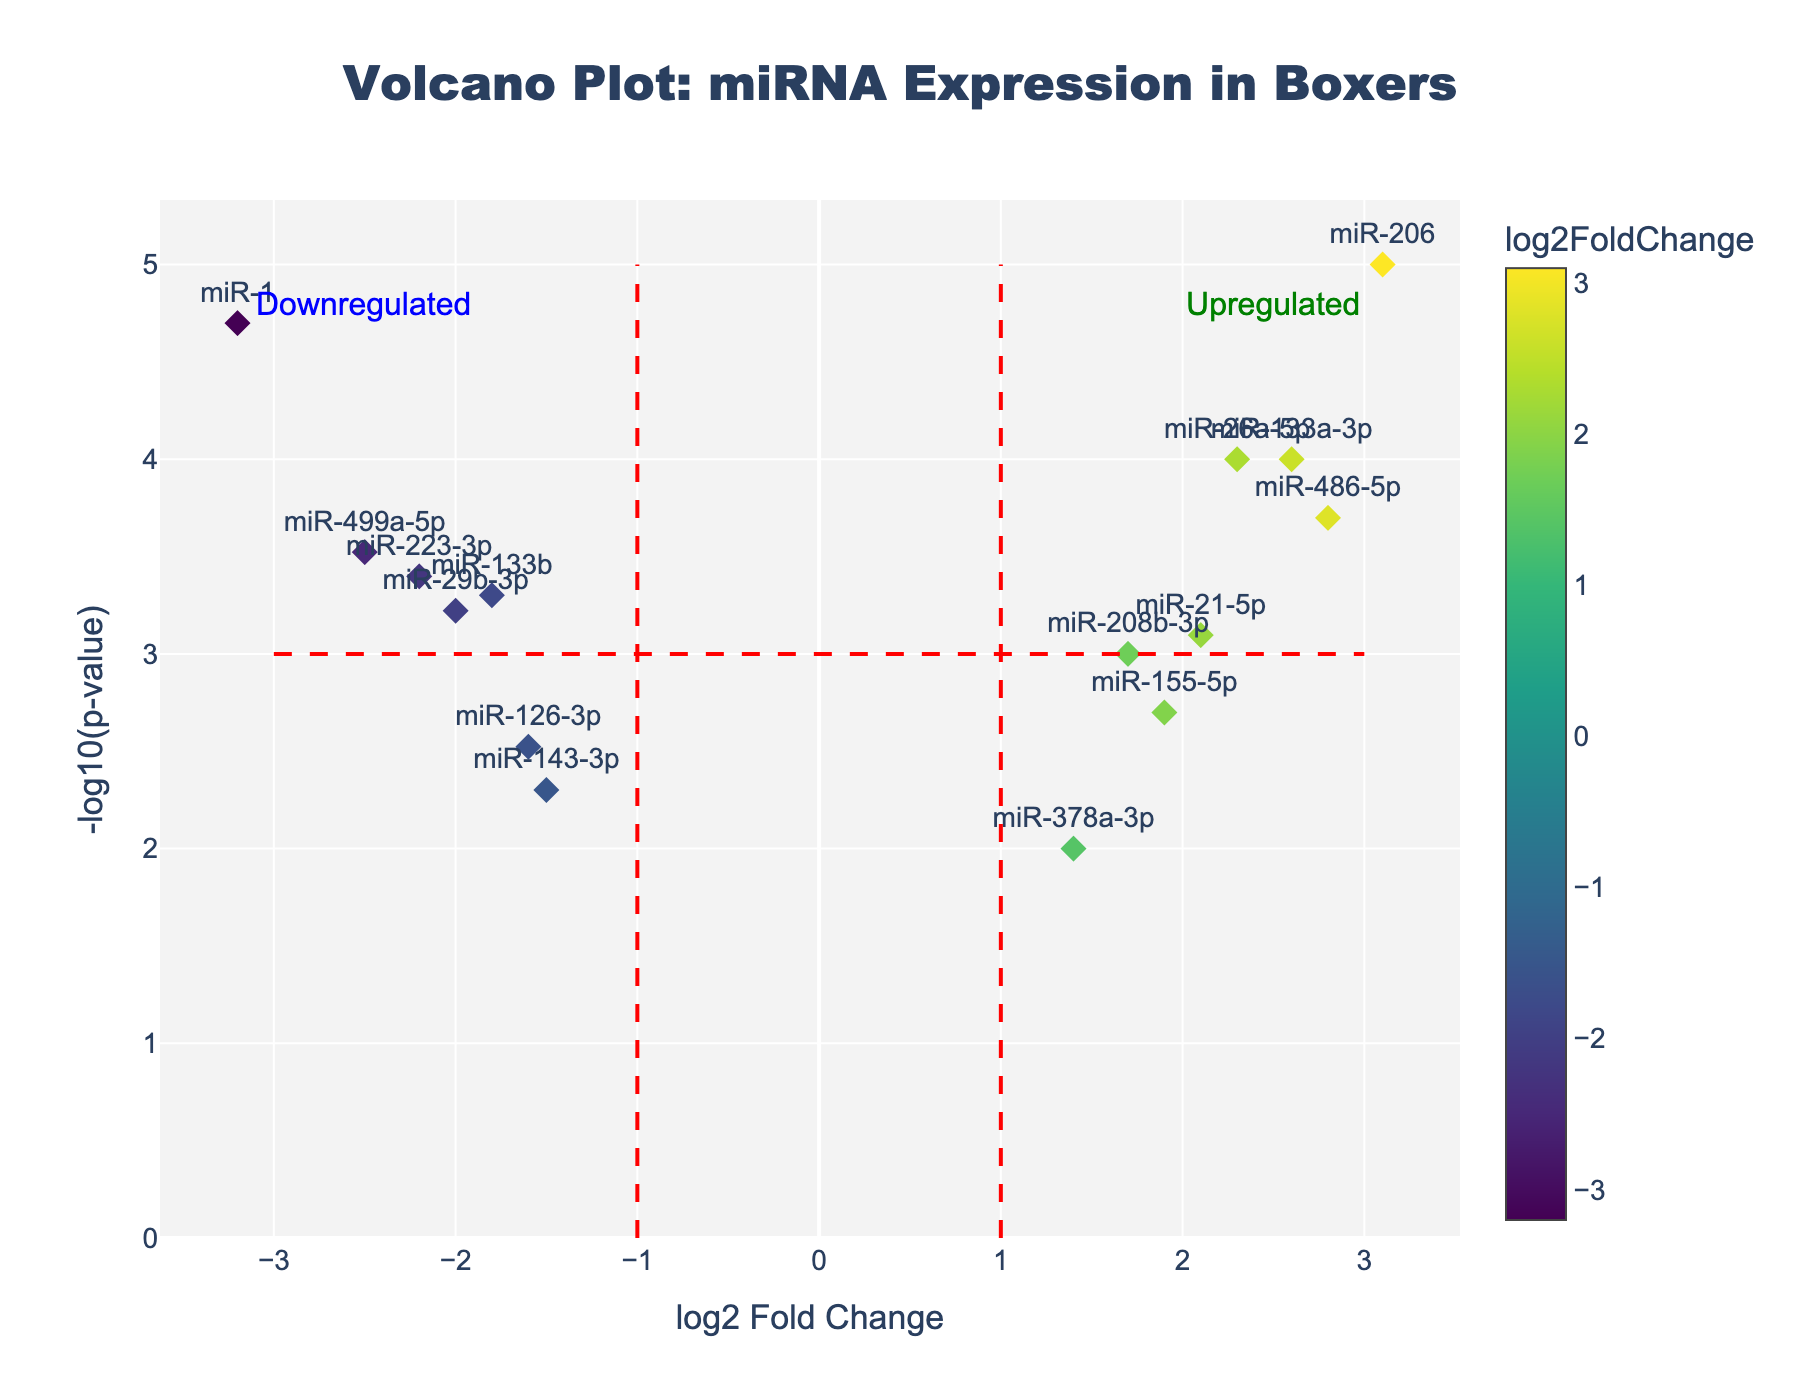Which miRNA has the highest -log10(p-value)? The highest -log10(p-value) value means the most significant p-value. By looking at the y-axis of the Volcano Plot, miR-206 is at the highest point.
Answer: miR-206 How many miRNAs are showing a log2 Fold Change greater than 2? Count the data points on the x-axis that are positioned to the right of 2. The miRNAs miR-26a-5p, miR-206, miR-486-5p, and miR-133a-3p are the ones greater than 2.
Answer: 4 Which miRNA is most downregulated and what is its log2 Fold Change value? The most downregulated miRNA will have the lowest log2 Fold Change value. miR-1 is shown on the leftmost side of the x-axis indicating log2 Fold Change of -3.2.
Answer: miR-1 What does the red dashed vertical line at 1 on the x-axis represent? The red dashed line indicates a threshold for log2 fold change. miRNAs to the right of this line are considered upregulated with log2 fold changes greater than 1.
Answer: Upregulation threshold Which miRNAs have p-values less significant than 0.001? This is shown by looking at the points with -log10(p-value) less than 3. These miRNAs are miR-21-5p, miR-208b-3p, miR-29b-3p, miR-155-5p, miR-126-3p, miR-143-3p, and miR-378a-3p.
Answer: 7 miRNAs (miR-21-5p, miR-208b-3p, miR-29b-3p, miR-155-5p, miR-126-3p, miR-143-3p, miR-378a-3p) Is miR-223-3p significantly downregulated? Check the log2 Fold Change and -log10(p-value) for miR-223-3p. It has a negative log2 Fold Change and a -log10(p-value) greater than 3. It crosses both thresholds for significance.
Answer: Yes Compare the p-value significance between miR-26a-5p and miR-499a-5p. Which one is more significant? By comparing their -log10(p-value) values, miR-26a-5p has a -log10(p-value) of 4, while miR-499a-5p has around 3.52. Therefore, miR-26a-5p is more significant.
Answer: miR-26a-5p How many miRNAs are classified as upregulated according to the plot? Upregulated miRNAs will have log2 Fold Change values greater than 1. Counting the data points situated to the right of the 1 line provides the number, which is 7.
Answer: 7 